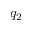<formula> <loc_0><loc_0><loc_500><loc_500>q _ { 2 }</formula> 